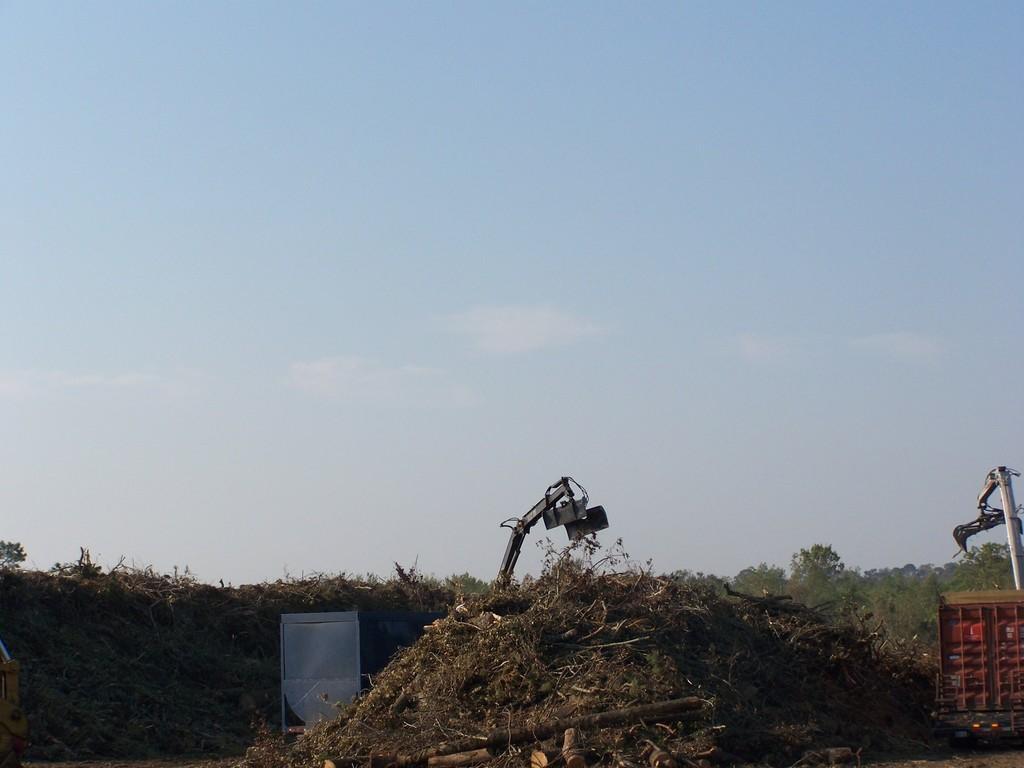Describe this image in one or two sentences. In this image I can see two cranes, in front I can see dried grass. Background I can see plants in green color and the sky is in white and blue color. 